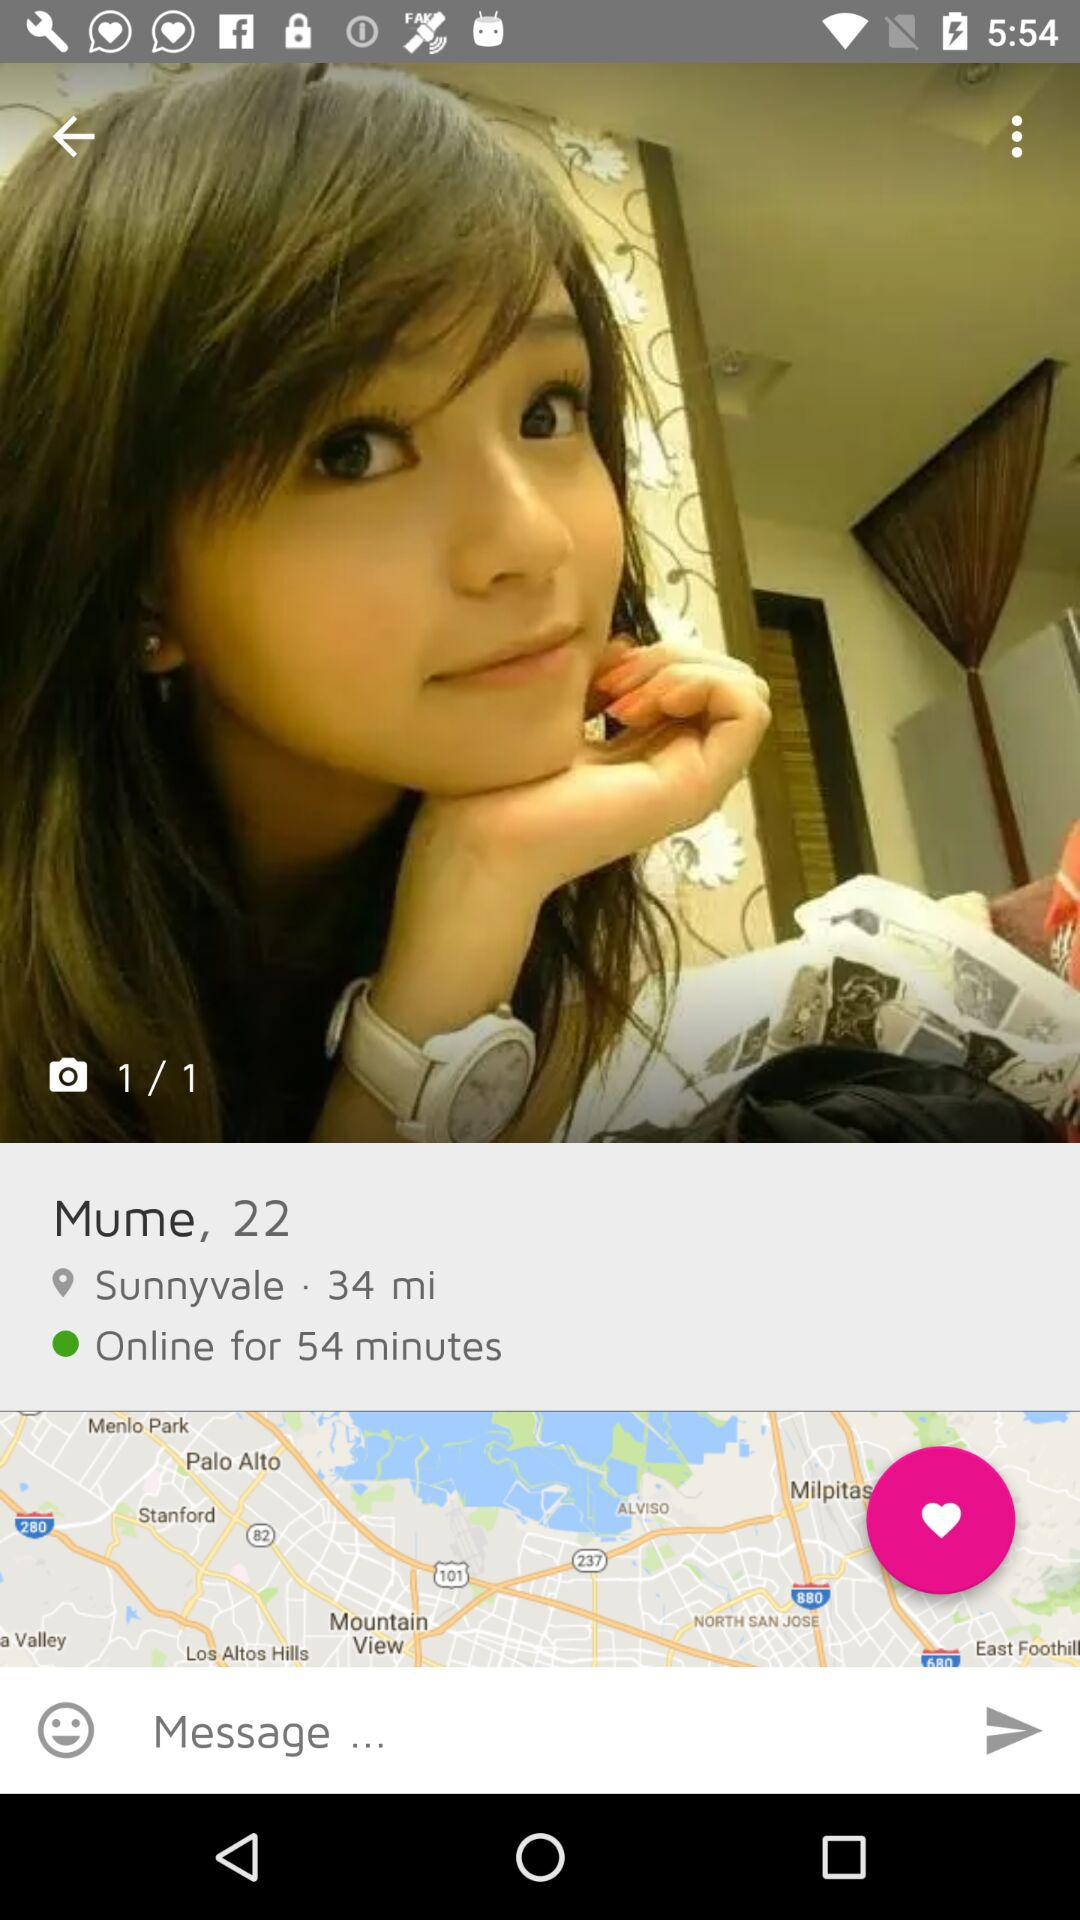What is the location? The location is Sunnyvale. 